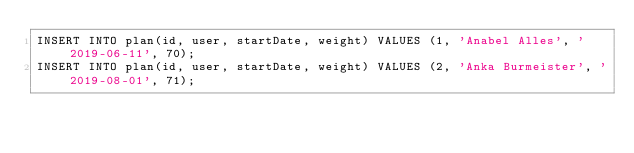Convert code to text. <code><loc_0><loc_0><loc_500><loc_500><_SQL_>INSERT INTO plan(id, user, startDate, weight) VALUES (1, 'Anabel Alles', '2019-06-11', 70);
INSERT INTO plan(id, user, startDate, weight) VALUES (2, 'Anka Burmeister', '2019-08-01', 71);</code> 